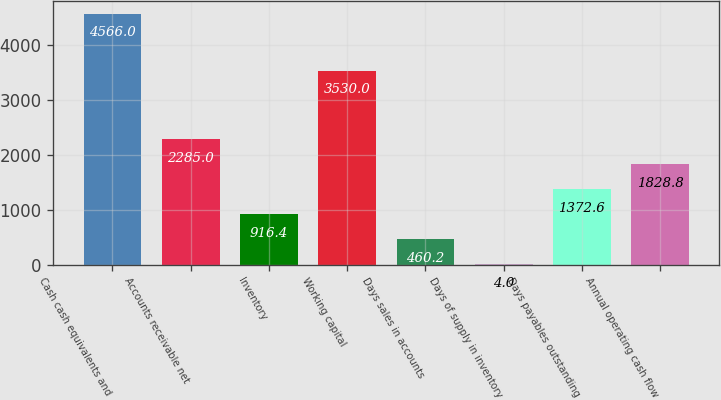Convert chart to OTSL. <chart><loc_0><loc_0><loc_500><loc_500><bar_chart><fcel>Cash cash equivalents and<fcel>Accounts receivable net<fcel>Inventory<fcel>Working capital<fcel>Days sales in accounts<fcel>Days of supply in inventory<fcel>Days payables outstanding<fcel>Annual operating cash flow<nl><fcel>4566<fcel>2285<fcel>916.4<fcel>3530<fcel>460.2<fcel>4<fcel>1372.6<fcel>1828.8<nl></chart> 